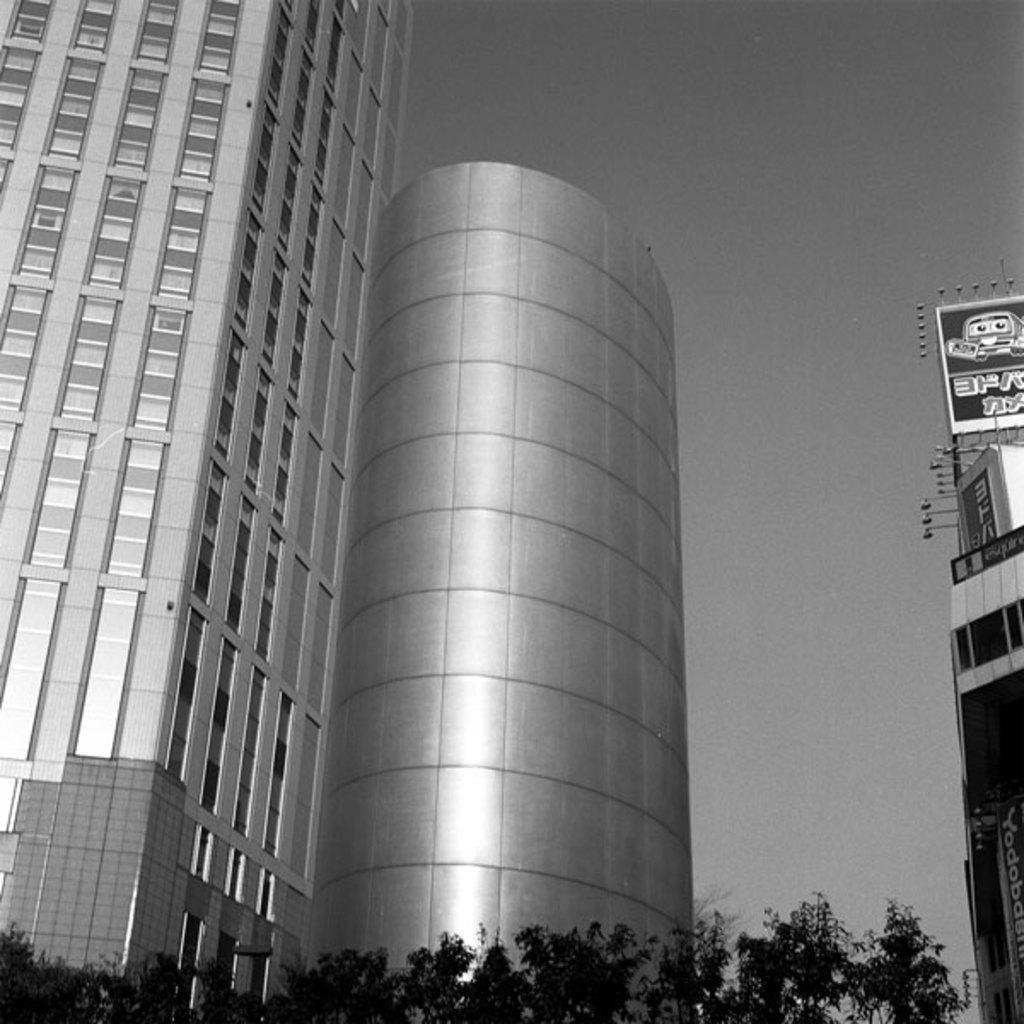What type of structures can be seen in the image? There are buildings in the image. What other objects are present in the image besides buildings? There are hoardings and trees in the image. What type of polish is being applied to the ship in the image? There is no ship present in the image, so it is not possible to determine if any polish is being applied. 